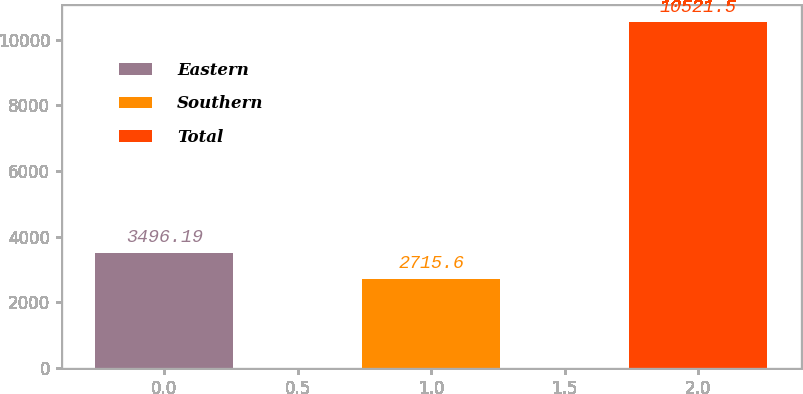Convert chart to OTSL. <chart><loc_0><loc_0><loc_500><loc_500><bar_chart><fcel>Eastern<fcel>Southern<fcel>Total<nl><fcel>3496.19<fcel>2715.6<fcel>10521.5<nl></chart> 